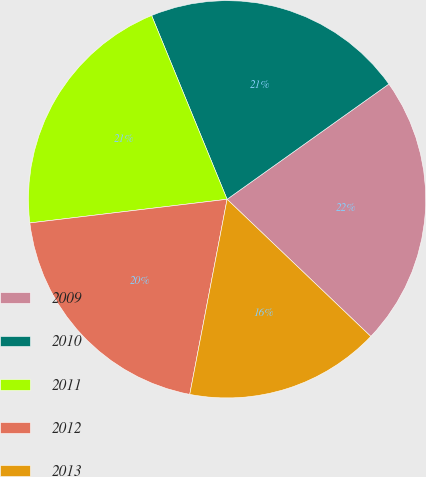Convert chart. <chart><loc_0><loc_0><loc_500><loc_500><pie_chart><fcel>2009<fcel>2010<fcel>2011<fcel>2012<fcel>2013<nl><fcel>21.98%<fcel>21.35%<fcel>20.7%<fcel>20.09%<fcel>15.88%<nl></chart> 